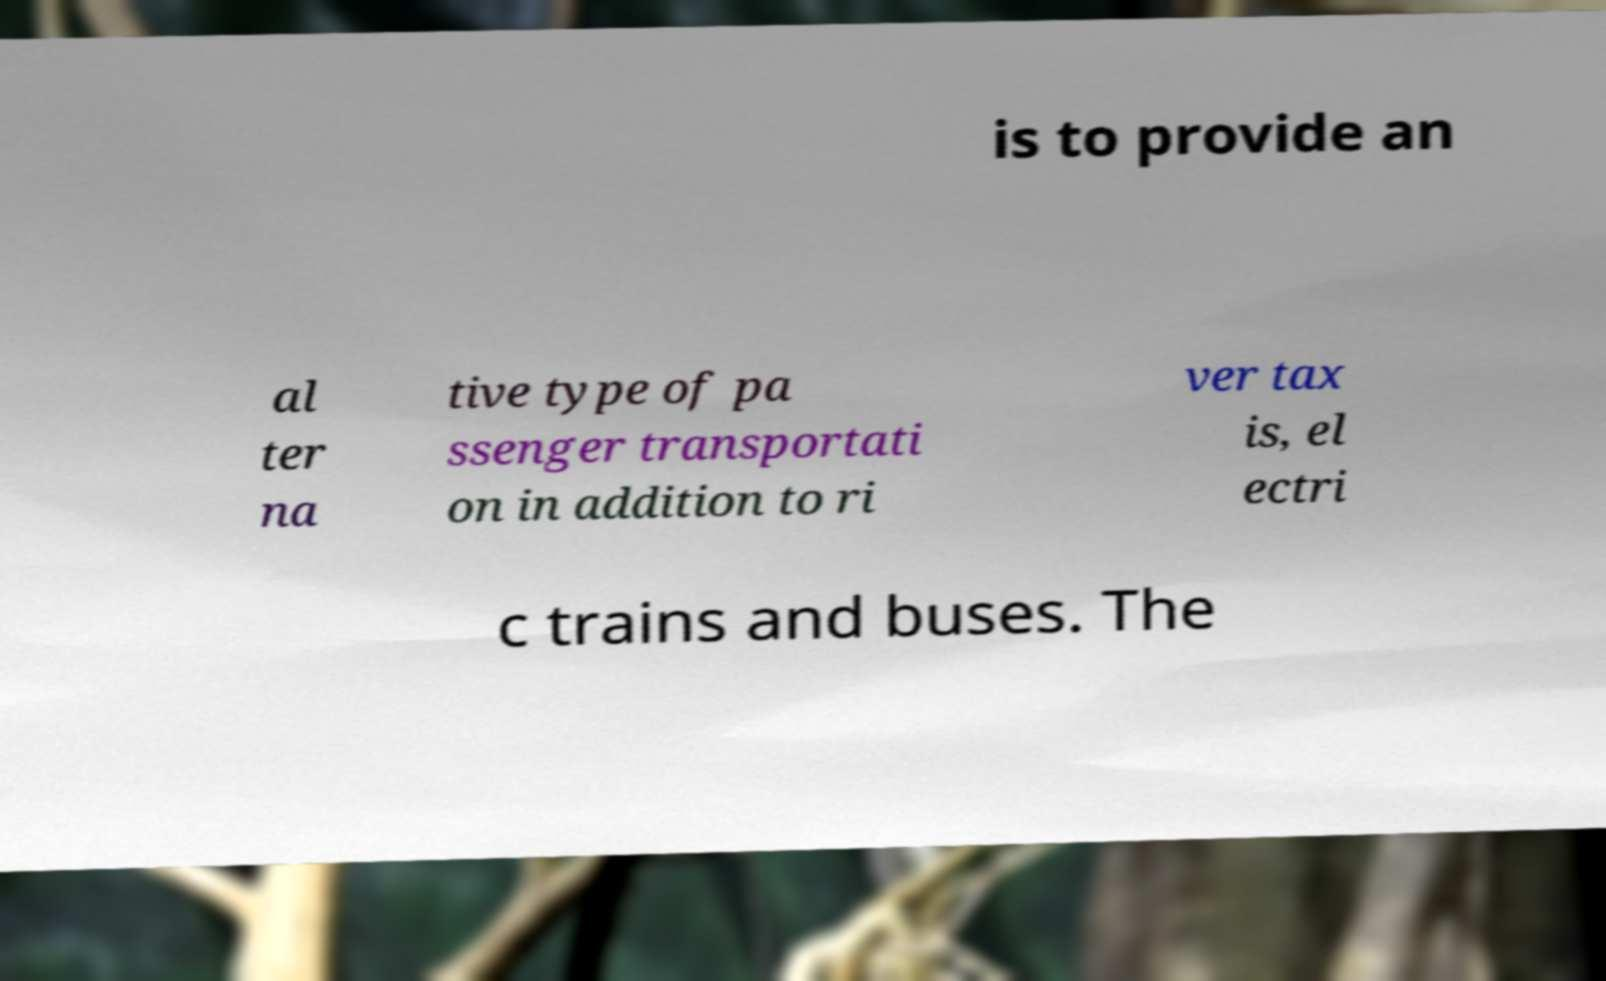Could you assist in decoding the text presented in this image and type it out clearly? is to provide an al ter na tive type of pa ssenger transportati on in addition to ri ver tax is, el ectri c trains and buses. The 